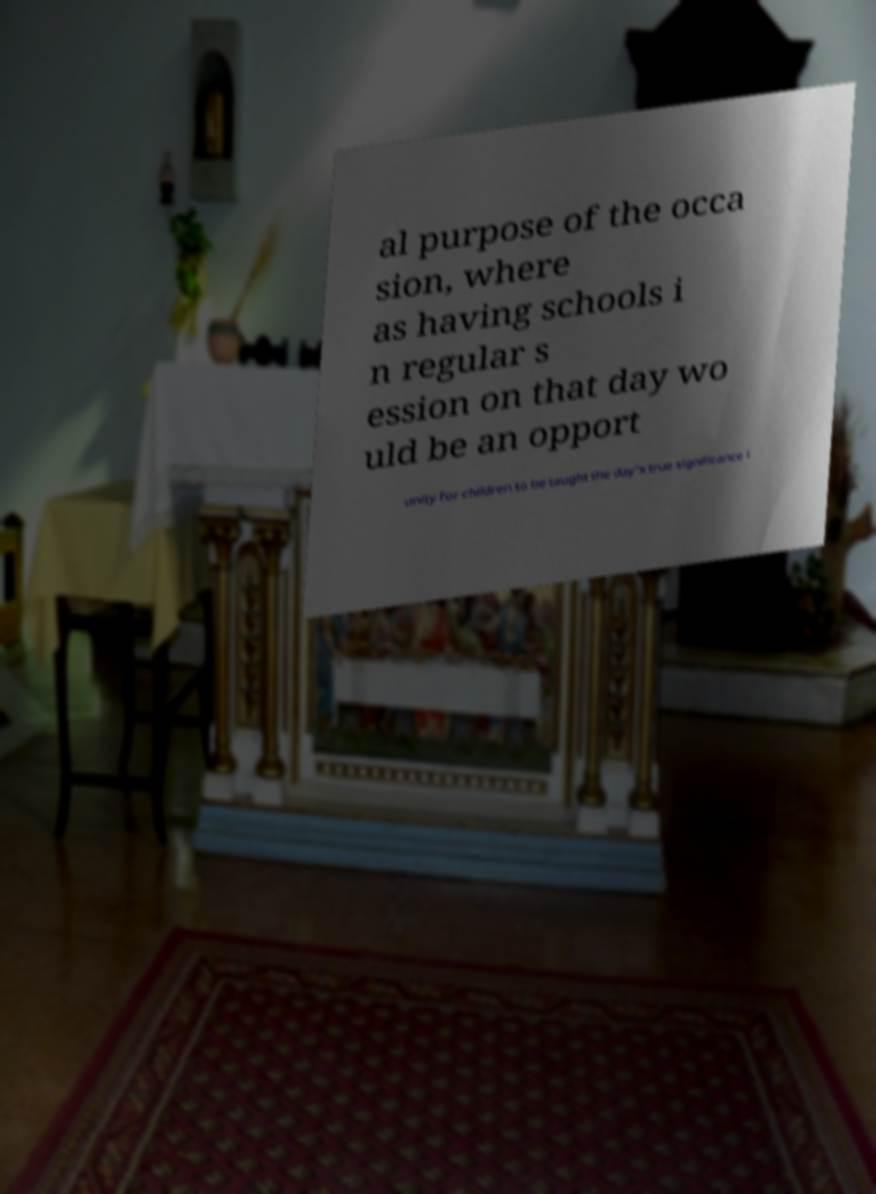Please identify and transcribe the text found in this image. al purpose of the occa sion, where as having schools i n regular s ession on that day wo uld be an opport unity for children to be taught the day's true significance i 